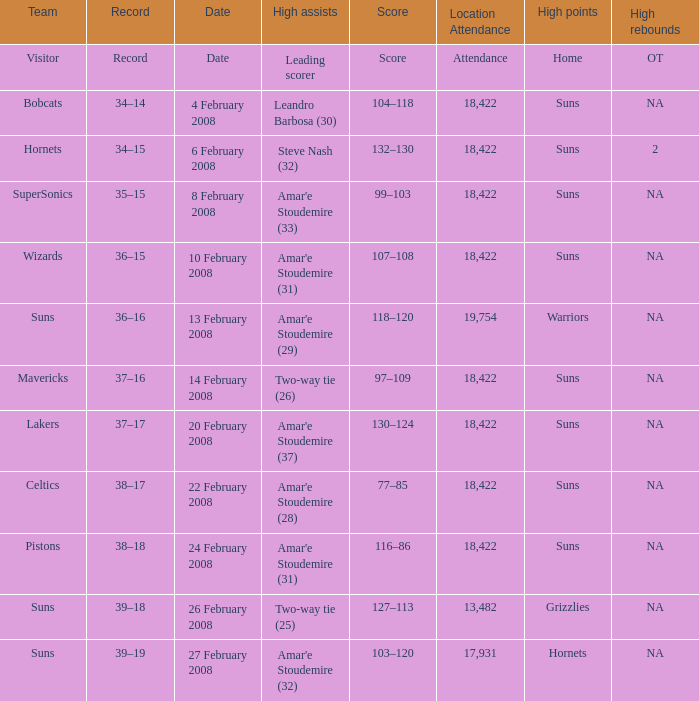How many high assists did the Lakers have? Amar'e Stoudemire (37). 